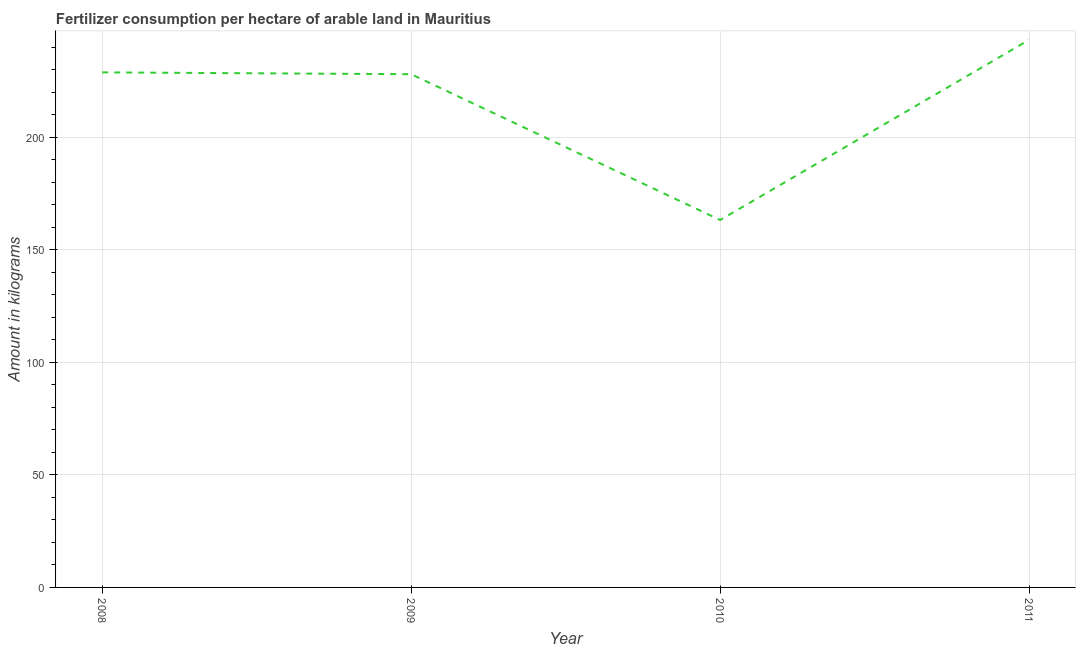What is the amount of fertilizer consumption in 2009?
Your answer should be compact. 227.96. Across all years, what is the maximum amount of fertilizer consumption?
Provide a succinct answer. 243.23. Across all years, what is the minimum amount of fertilizer consumption?
Keep it short and to the point. 163.2. In which year was the amount of fertilizer consumption minimum?
Offer a very short reply. 2010. What is the sum of the amount of fertilizer consumption?
Give a very brief answer. 863.17. What is the difference between the amount of fertilizer consumption in 2008 and 2011?
Offer a terse response. -14.46. What is the average amount of fertilizer consumption per year?
Give a very brief answer. 215.79. What is the median amount of fertilizer consumption?
Keep it short and to the point. 228.37. Do a majority of the years between 2009 and 2011 (inclusive) have amount of fertilizer consumption greater than 20 kg?
Your answer should be compact. Yes. What is the ratio of the amount of fertilizer consumption in 2010 to that in 2011?
Your response must be concise. 0.67. Is the difference between the amount of fertilizer consumption in 2009 and 2010 greater than the difference between any two years?
Offer a terse response. No. What is the difference between the highest and the second highest amount of fertilizer consumption?
Provide a short and direct response. 14.46. Is the sum of the amount of fertilizer consumption in 2010 and 2011 greater than the maximum amount of fertilizer consumption across all years?
Your answer should be very brief. Yes. What is the difference between the highest and the lowest amount of fertilizer consumption?
Make the answer very short. 80.03. In how many years, is the amount of fertilizer consumption greater than the average amount of fertilizer consumption taken over all years?
Ensure brevity in your answer.  3. How many years are there in the graph?
Provide a succinct answer. 4. What is the difference between two consecutive major ticks on the Y-axis?
Ensure brevity in your answer.  50. Are the values on the major ticks of Y-axis written in scientific E-notation?
Give a very brief answer. No. Does the graph contain grids?
Offer a terse response. Yes. What is the title of the graph?
Provide a short and direct response. Fertilizer consumption per hectare of arable land in Mauritius . What is the label or title of the Y-axis?
Offer a very short reply. Amount in kilograms. What is the Amount in kilograms of 2008?
Keep it short and to the point. 228.78. What is the Amount in kilograms in 2009?
Give a very brief answer. 227.96. What is the Amount in kilograms of 2010?
Provide a succinct answer. 163.2. What is the Amount in kilograms in 2011?
Keep it short and to the point. 243.23. What is the difference between the Amount in kilograms in 2008 and 2009?
Give a very brief answer. 0.81. What is the difference between the Amount in kilograms in 2008 and 2010?
Offer a very short reply. 65.58. What is the difference between the Amount in kilograms in 2008 and 2011?
Your answer should be compact. -14.46. What is the difference between the Amount in kilograms in 2009 and 2010?
Provide a short and direct response. 64.76. What is the difference between the Amount in kilograms in 2009 and 2011?
Your answer should be very brief. -15.27. What is the difference between the Amount in kilograms in 2010 and 2011?
Keep it short and to the point. -80.03. What is the ratio of the Amount in kilograms in 2008 to that in 2009?
Offer a terse response. 1. What is the ratio of the Amount in kilograms in 2008 to that in 2010?
Your answer should be very brief. 1.4. What is the ratio of the Amount in kilograms in 2008 to that in 2011?
Your response must be concise. 0.94. What is the ratio of the Amount in kilograms in 2009 to that in 2010?
Provide a short and direct response. 1.4. What is the ratio of the Amount in kilograms in 2009 to that in 2011?
Your response must be concise. 0.94. What is the ratio of the Amount in kilograms in 2010 to that in 2011?
Your response must be concise. 0.67. 